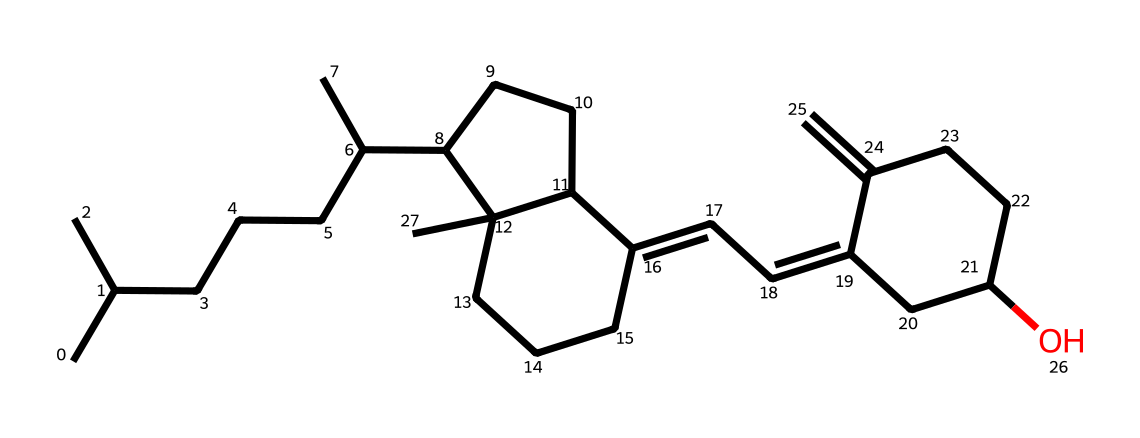what is the name of this chemical? The SMILES representation indicates a chemical structure corresponding to Vitamin D, specifically Vitamin D2 or ergocalciferol. The structural features align with known compounds of this category.
Answer: Vitamin D2 how many carbon atoms are present in the structure? By analyzing the SMILES, each 'C' in the representation corresponds to a carbon atom. Counting all 'C' characters together reveals that there are 27 carbon atoms in total.
Answer: 27 how many rings does this chemical structure have? The structuring of the SMILES shows closed loops where there are numbers indicating bond closures, and by accounting these, it is evident that there are four distinct rings in this structure.
Answer: 4 which functional group is present in this chemical? The SMILES representation includes an 'O,' which indicates the presence of a hydroxyl group (-OH) often seen in alcohols. The presence of 'C' connected to 'O' also confirms the -OH functional group in the chemical structure.
Answer: hydroxyl is this compound a steroid? The presence of multiple fused rings and a characteristic hydrocarbon chain suggests that this compound fits the structural profile of steroids, confirming it qualifies as a steroid.
Answer: yes what is the degree of unsaturation in this compound? Degree of unsaturation can be calculated from the formula U = C - (H/2) + (N/2) + 1. With the carbon and hydrogen counts from the SMILES, the analysis indicates a moderate level of unsaturation, calculated to be 6 for this compound.
Answer: 6 does this chemical have any stereocenters? A stereocenter is identified by a carbon atom connected to four different substituents. In examining the structure from the SMILES, it is identified that there are indeed four stereocenters present in this vitamin D structure.
Answer: 4 